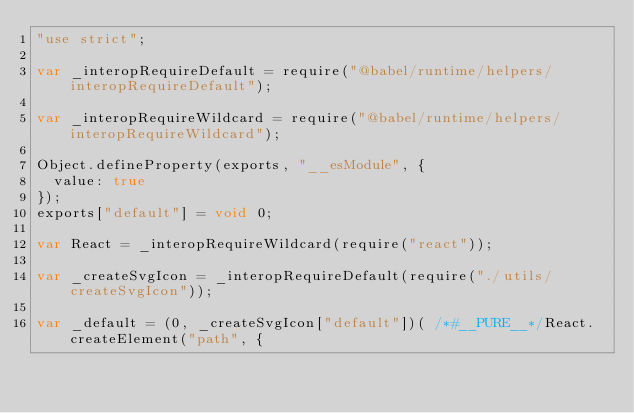Convert code to text. <code><loc_0><loc_0><loc_500><loc_500><_JavaScript_>"use strict";

var _interopRequireDefault = require("@babel/runtime/helpers/interopRequireDefault");

var _interopRequireWildcard = require("@babel/runtime/helpers/interopRequireWildcard");

Object.defineProperty(exports, "__esModule", {
  value: true
});
exports["default"] = void 0;

var React = _interopRequireWildcard(require("react"));

var _createSvgIcon = _interopRequireDefault(require("./utils/createSvgIcon"));

var _default = (0, _createSvgIcon["default"])( /*#__PURE__*/React.createElement("path", {</code> 